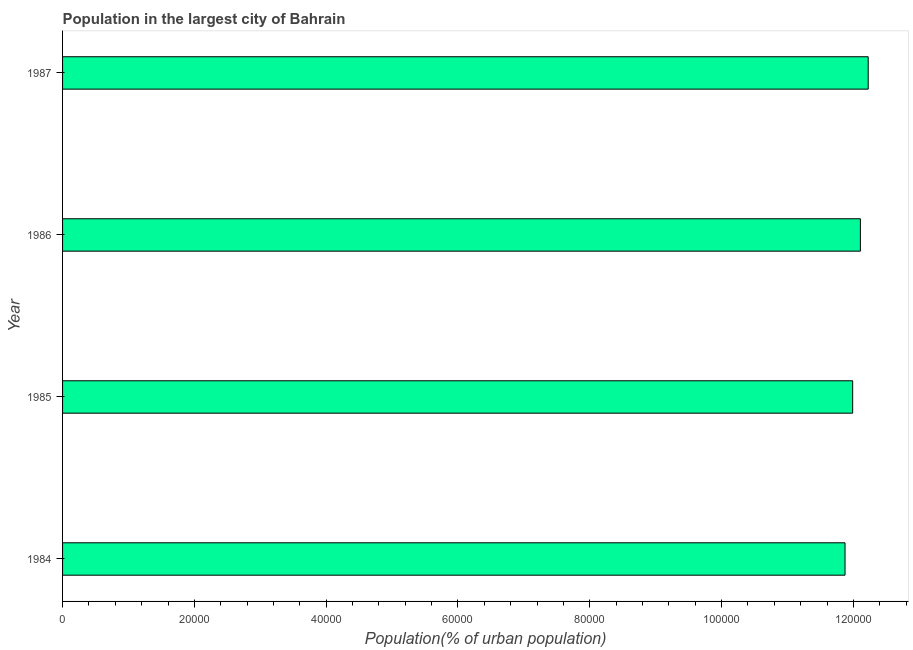Does the graph contain any zero values?
Make the answer very short. No. Does the graph contain grids?
Keep it short and to the point. No. What is the title of the graph?
Your answer should be very brief. Population in the largest city of Bahrain. What is the label or title of the X-axis?
Give a very brief answer. Population(% of urban population). What is the label or title of the Y-axis?
Ensure brevity in your answer.  Year. What is the population in largest city in 1984?
Give a very brief answer. 1.19e+05. Across all years, what is the maximum population in largest city?
Keep it short and to the point. 1.22e+05. Across all years, what is the minimum population in largest city?
Your answer should be very brief. 1.19e+05. In which year was the population in largest city maximum?
Keep it short and to the point. 1987. What is the sum of the population in largest city?
Offer a terse response. 4.82e+05. What is the difference between the population in largest city in 1986 and 1987?
Keep it short and to the point. -1184. What is the average population in largest city per year?
Your answer should be compact. 1.20e+05. What is the median population in largest city?
Give a very brief answer. 1.20e+05. What is the ratio of the population in largest city in 1985 to that in 1986?
Give a very brief answer. 0.99. Is the population in largest city in 1984 less than that in 1986?
Ensure brevity in your answer.  Yes. Is the difference between the population in largest city in 1984 and 1985 greater than the difference between any two years?
Offer a terse response. No. What is the difference between the highest and the second highest population in largest city?
Make the answer very short. 1184. What is the difference between the highest and the lowest population in largest city?
Keep it short and to the point. 3517. In how many years, is the population in largest city greater than the average population in largest city taken over all years?
Offer a very short reply. 2. How many bars are there?
Make the answer very short. 4. Are all the bars in the graph horizontal?
Keep it short and to the point. Yes. Are the values on the major ticks of X-axis written in scientific E-notation?
Your response must be concise. No. What is the Population(% of urban population) of 1984?
Your answer should be very brief. 1.19e+05. What is the Population(% of urban population) of 1985?
Your answer should be very brief. 1.20e+05. What is the Population(% of urban population) of 1986?
Provide a short and direct response. 1.21e+05. What is the Population(% of urban population) in 1987?
Provide a succinct answer. 1.22e+05. What is the difference between the Population(% of urban population) in 1984 and 1985?
Your answer should be compact. -1160. What is the difference between the Population(% of urban population) in 1984 and 1986?
Provide a succinct answer. -2333. What is the difference between the Population(% of urban population) in 1984 and 1987?
Give a very brief answer. -3517. What is the difference between the Population(% of urban population) in 1985 and 1986?
Your response must be concise. -1173. What is the difference between the Population(% of urban population) in 1985 and 1987?
Provide a succinct answer. -2357. What is the difference between the Population(% of urban population) in 1986 and 1987?
Provide a short and direct response. -1184. What is the ratio of the Population(% of urban population) in 1984 to that in 1985?
Your response must be concise. 0.99. What is the ratio of the Population(% of urban population) in 1984 to that in 1987?
Your response must be concise. 0.97. What is the ratio of the Population(% of urban population) in 1985 to that in 1987?
Offer a very short reply. 0.98. What is the ratio of the Population(% of urban population) in 1986 to that in 1987?
Offer a very short reply. 0.99. 